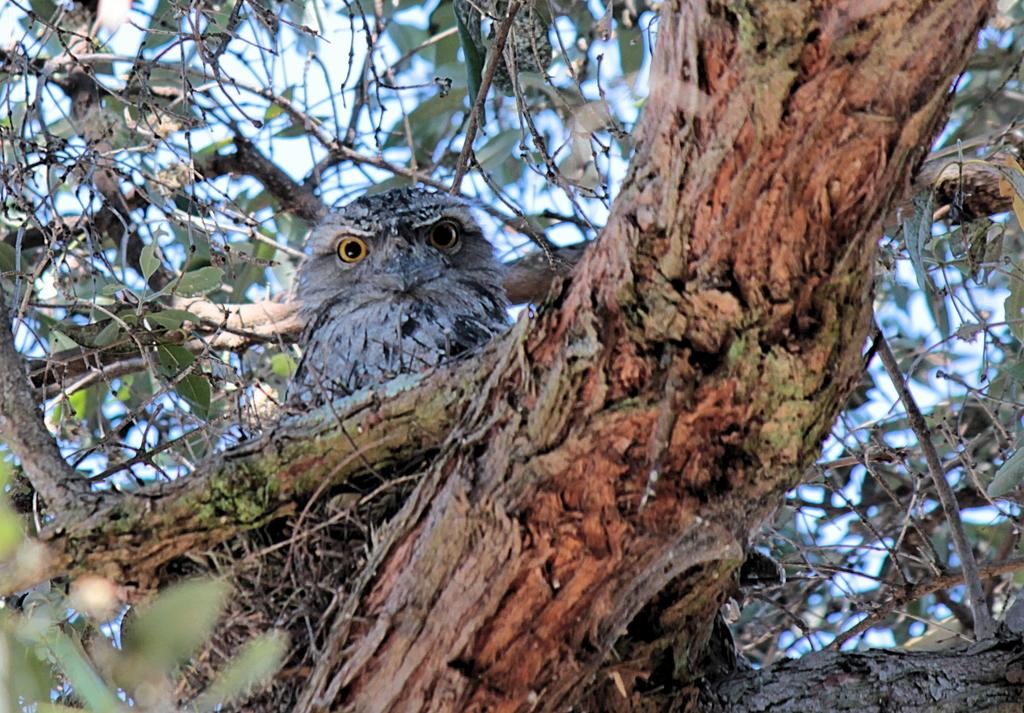What type of animal can be seen in the image? There is a bird in the image. Where is the bird located? The bird is in a nest. What is the nest resting on? The nest is on a branch of a tree. What is the condition of the tree? The tree has leaves. What can be seen in the background of the image? The sky is visible in the background of the image. How does the bird use a zipper to secure its nest? There is no zipper present in the image; the bird's nest is secured on a branch of a tree. 